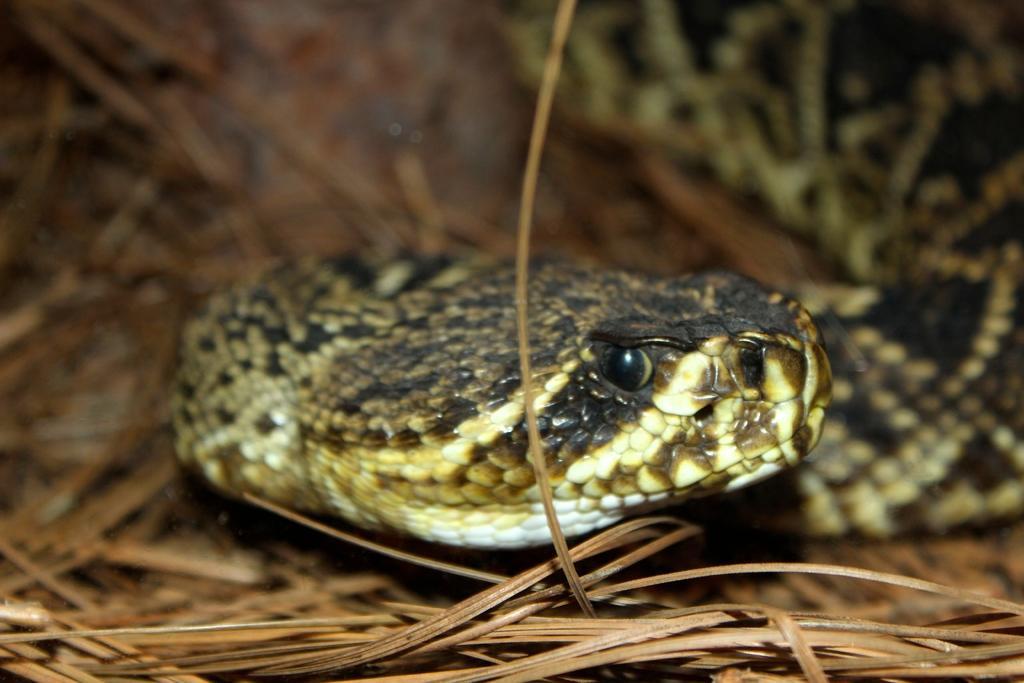In one or two sentences, can you explain what this image depicts? In the center of the image we can see a snake. At the bottom we can see grass. 